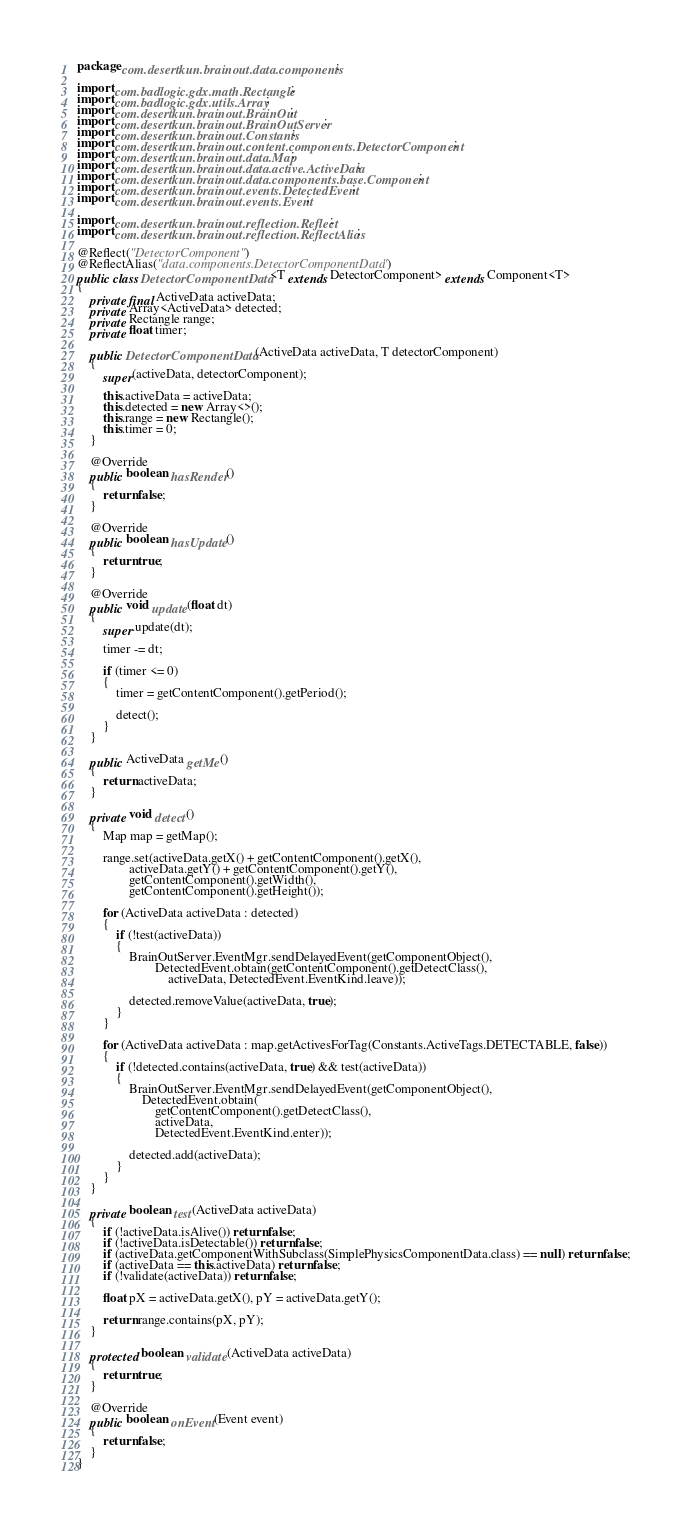<code> <loc_0><loc_0><loc_500><loc_500><_Java_>package com.desertkun.brainout.data.components;

import com.badlogic.gdx.math.Rectangle;
import com.badlogic.gdx.utils.Array;
import com.desertkun.brainout.BrainOut;
import com.desertkun.brainout.BrainOutServer;
import com.desertkun.brainout.Constants;
import com.desertkun.brainout.content.components.DetectorComponent;
import com.desertkun.brainout.data.Map;
import com.desertkun.brainout.data.active.ActiveData;
import com.desertkun.brainout.data.components.base.Component;
import com.desertkun.brainout.events.DetectedEvent;
import com.desertkun.brainout.events.Event;

import com.desertkun.brainout.reflection.Reflect;
import com.desertkun.brainout.reflection.ReflectAlias;

@Reflect("DetectorComponent")
@ReflectAlias("data.components.DetectorComponentData")
public class DetectorComponentData<T extends DetectorComponent> extends Component<T>
{
    private final ActiveData activeData;
    private Array<ActiveData> detected;
    private Rectangle range;
    private float timer;

    public DetectorComponentData(ActiveData activeData, T detectorComponent)
    {
        super(activeData, detectorComponent);

        this.activeData = activeData;
        this.detected = new Array<>();
        this.range = new Rectangle();
        this.timer = 0;
    }

    @Override
    public boolean hasRender()
    {
        return false;
    }

    @Override
    public boolean hasUpdate()
    {
        return true;
    }

    @Override
    public void update(float dt)
    {
        super.update(dt);

        timer -= dt;

        if (timer <= 0)
        {
            timer = getContentComponent().getPeriod();

            detect();
        }
    }

    public ActiveData getMe()
    {
        return activeData;
    }

    private void detect()
    {
        Map map = getMap();

        range.set(activeData.getX() + getContentComponent().getX(),
                activeData.getY() + getContentComponent().getY(),
                getContentComponent().getWidth(),
                getContentComponent().getHeight());

        for (ActiveData activeData : detected)
        {
            if (!test(activeData))
            {
                BrainOutServer.EventMgr.sendDelayedEvent(getComponentObject(),
                        DetectedEvent.obtain(getContentComponent().getDetectClass(),
                            activeData, DetectedEvent.EventKind.leave));

                detected.removeValue(activeData, true);
            }
        }

        for (ActiveData activeData : map.getActivesForTag(Constants.ActiveTags.DETECTABLE, false))
        {
            if (!detected.contains(activeData, true) && test(activeData))
            {
                BrainOutServer.EventMgr.sendDelayedEvent(getComponentObject(),
                    DetectedEvent.obtain(
                        getContentComponent().getDetectClass(),
                        activeData,
                        DetectedEvent.EventKind.enter));

                detected.add(activeData);
            }
        }
    }

    private boolean test(ActiveData activeData)
    {
        if (!activeData.isAlive()) return false;
        if (!activeData.isDetectable()) return false;
        if (activeData.getComponentWithSubclass(SimplePhysicsComponentData.class) == null) return false;
        if (activeData == this.activeData) return false;
        if (!validate(activeData)) return false;

        float pX = activeData.getX(), pY = activeData.getY();

        return range.contains(pX, pY);
    }

    protected boolean validate(ActiveData activeData)
    {
        return true;
    }

    @Override
    public boolean onEvent(Event event)
    {
        return false;
    }
}
</code> 